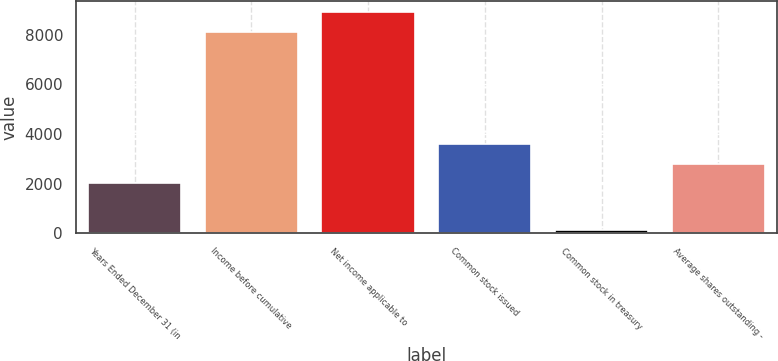Convert chart to OTSL. <chart><loc_0><loc_0><loc_500><loc_500><bar_chart><fcel>Years Ended December 31 (in<fcel>Income before cumulative<fcel>Net income applicable to<fcel>Common stock issued<fcel>Common stock in treasury<fcel>Average shares outstanding -<nl><fcel>2003<fcel>8099<fcel>8895.6<fcel>3596.2<fcel>142<fcel>2799.6<nl></chart> 